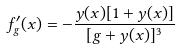Convert formula to latex. <formula><loc_0><loc_0><loc_500><loc_500>f _ { g } ^ { \prime } ( x ) = - \frac { y ( x ) [ 1 + y ( x ) ] } { [ g + y ( x ) ] ^ { 3 } }</formula> 